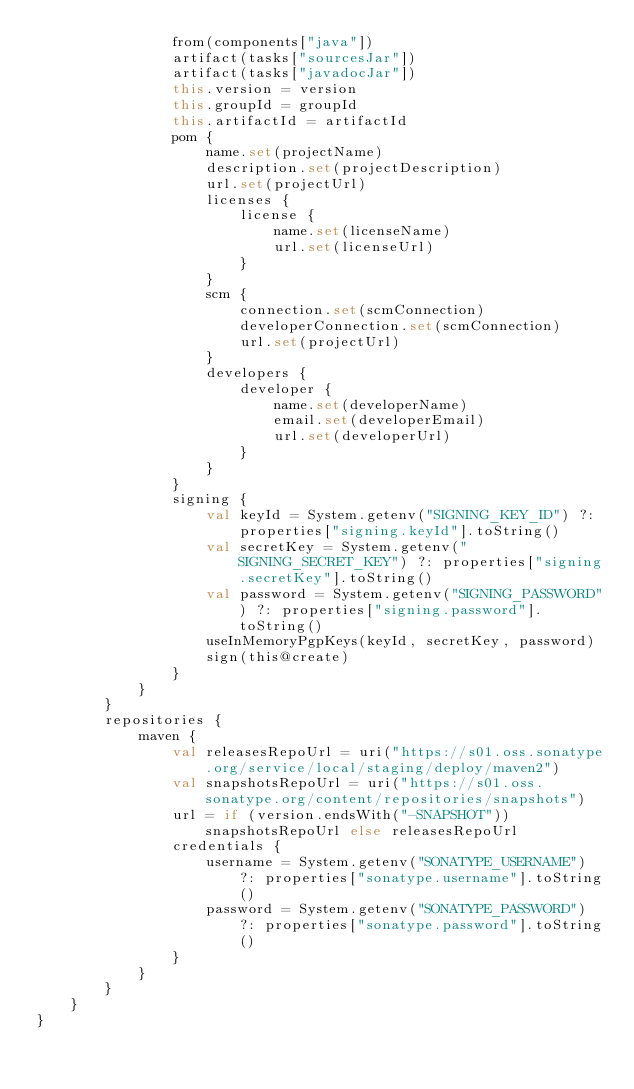Convert code to text. <code><loc_0><loc_0><loc_500><loc_500><_Kotlin_>                from(components["java"])
                artifact(tasks["sourcesJar"])
                artifact(tasks["javadocJar"])
                this.version = version
                this.groupId = groupId
                this.artifactId = artifactId
                pom {
                    name.set(projectName)
                    description.set(projectDescription)
                    url.set(projectUrl)
                    licenses {
                        license {
                            name.set(licenseName)
                            url.set(licenseUrl)
                        }
                    }
                    scm {
                        connection.set(scmConnection)
                        developerConnection.set(scmConnection)
                        url.set(projectUrl)
                    }
                    developers {
                        developer {
                            name.set(developerName)
                            email.set(developerEmail)
                            url.set(developerUrl)
                        }
                    }
                }
                signing {
                    val keyId = System.getenv("SIGNING_KEY_ID") ?: properties["signing.keyId"].toString()
                    val secretKey = System.getenv("SIGNING_SECRET_KEY") ?: properties["signing.secretKey"].toString()
                    val password = System.getenv("SIGNING_PASSWORD") ?: properties["signing.password"].toString()
                    useInMemoryPgpKeys(keyId, secretKey, password)
                    sign(this@create)
                }
            }
        }
        repositories {
            maven {
                val releasesRepoUrl = uri("https://s01.oss.sonatype.org/service/local/staging/deploy/maven2")
                val snapshotsRepoUrl = uri("https://s01.oss.sonatype.org/content/repositories/snapshots")
                url = if (version.endsWith("-SNAPSHOT")) snapshotsRepoUrl else releasesRepoUrl
                credentials {
                    username = System.getenv("SONATYPE_USERNAME") ?: properties["sonatype.username"].toString()
                    password = System.getenv("SONATYPE_PASSWORD") ?: properties["sonatype.password"].toString()
                }
            }
        }
    }
}
</code> 